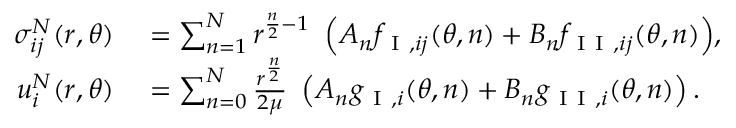<formula> <loc_0><loc_0><loc_500><loc_500>\begin{array} { r l } { \sigma _ { i j } ^ { N } ( r , \theta ) } & = \sum _ { n = 1 } ^ { N } { r ^ { \frac { n } { 2 } - 1 } \ \left ( A _ { n } f _ { I , i j } ( \theta , n ) + B _ { n } f _ { I I , i j } ( \theta , n ) \right ) } , } \\ { u _ { i } ^ { N } ( r , \theta ) } & = \sum _ { n = 0 } ^ { N } \frac { r ^ { \frac { n } { 2 } } } { 2 \mu } \ \left ( A _ { n } g _ { I , i } ( \theta , n ) + B _ { n } g _ { I I , i } ( \theta , n ) \right ) . } \end{array}</formula> 